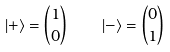<formula> <loc_0><loc_0><loc_500><loc_500>| + \rangle = { 1 \choose 0 } \, \quad | - \rangle = { 0 \choose 1 }</formula> 